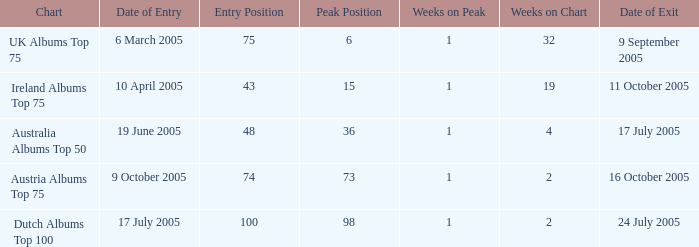Would you be able to parse every entry in this table? {'header': ['Chart', 'Date of Entry', 'Entry Position', 'Peak Position', 'Weeks on Peak', 'Weeks on Chart', 'Date of Exit'], 'rows': [['UK Albums Top 75', '6 March 2005', '75', '6', '1', '32', '9 September 2005'], ['Ireland Albums Top 75', '10 April 2005', '43', '15', '1', '19', '11 October 2005'], ['Australia Albums Top 50', '19 June 2005', '48', '36', '1', '4', '17 July 2005'], ['Austria Albums Top 75', '9 October 2005', '74', '73', '1', '2', '16 October 2005'], ['Dutch Albums Top 100', '17 July 2005', '100', '98', '1', '2', '24 July 2005']]} What is the exit date for the Dutch Albums Top 100 Chart? 24 July 2005. 